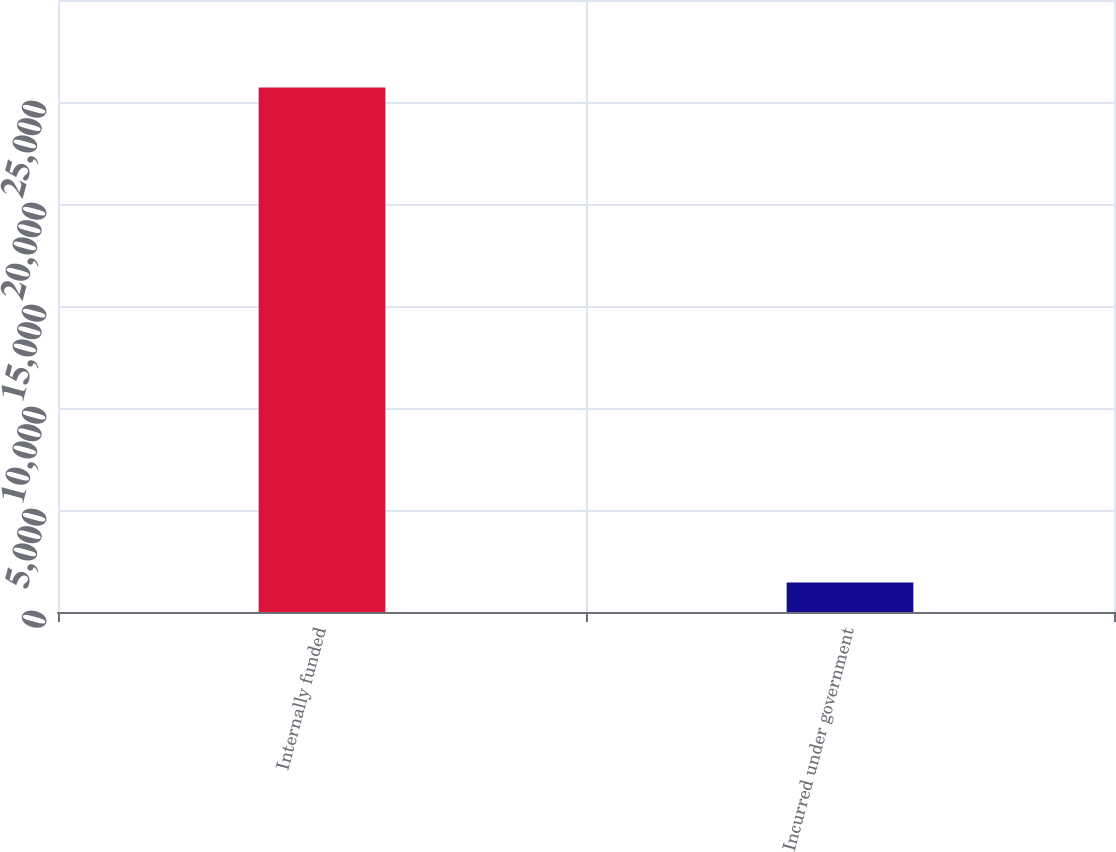<chart> <loc_0><loc_0><loc_500><loc_500><bar_chart><fcel>Internally funded<fcel>Incurred under government<nl><fcel>25715<fcel>1444<nl></chart> 